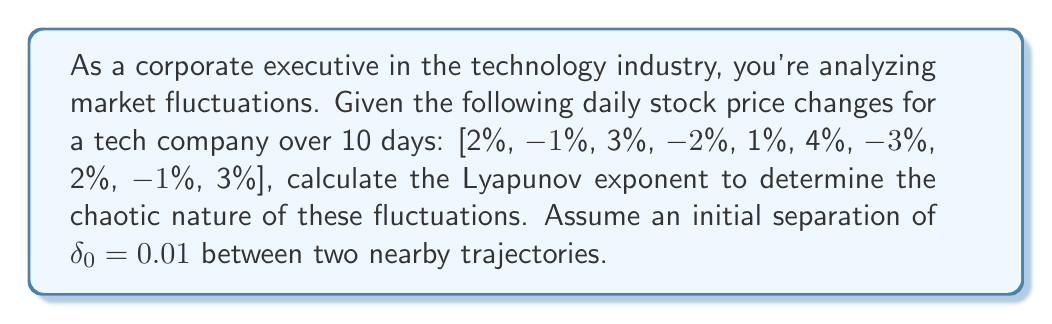Solve this math problem. To calculate the Lyapunov exponent for this time series:

1. Calculate the average rate of separation:
   $$\lambda = \frac{1}{N} \sum_{i=1}^N \ln\left|\frac{f'(x_i)\delta_0}{\delta_0}\right|$$
   where $N$ is the number of time steps, and $f'(x_i)$ is the rate of change at each point.

2. In this case, $f'(x_i)$ is represented by the daily percentage changes:
   $$f'(x_i) = [1.02, 0.99, 1.03, 0.98, 1.01, 1.04, 0.97, 1.02, 0.99, 1.03]$$

3. Calculate each term in the sum:
   $$\ln\left|\frac{1.02 \cdot 0.01}{0.01}\right| = \ln(1.02) = 0.0198
   \ln\left|\frac{0.99 \cdot 0.01}{0.01}\right| = \ln(0.99) = -0.0101
   \ln\left|\frac{1.03 \cdot 0.01}{0.01}\right| = \ln(1.03) = 0.0296
   ...
   \ln\left|\frac{1.03 \cdot 0.01}{0.01}\right| = \ln(1.03) = 0.0296$$

4. Sum all terms and divide by $N = 10$:
   $$\lambda = \frac{1}{10}(0.0198 - 0.0101 + 0.0296 - 0.0202 + 0.0100 + 0.0392 - 0.0305 + 0.0198 - 0.0101 + 0.0296)$$

5. Calculate the final result:
   $$\lambda = \frac{1}{10}(0.0771) = 0.00771$$
Answer: $\lambda \approx 0.00771$ 